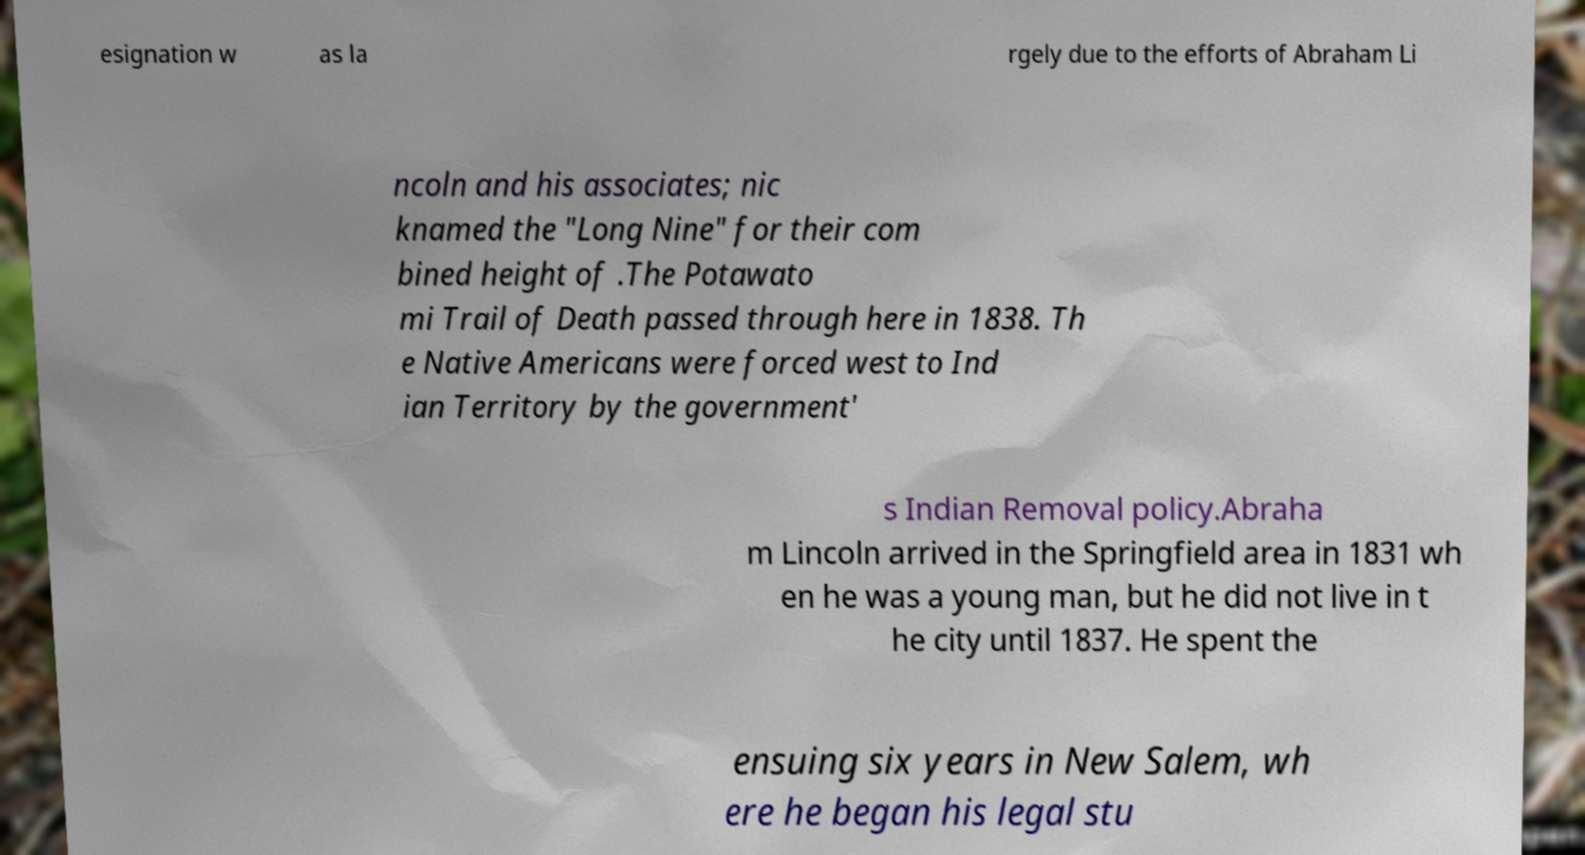There's text embedded in this image that I need extracted. Can you transcribe it verbatim? esignation w as la rgely due to the efforts of Abraham Li ncoln and his associates; nic knamed the "Long Nine" for their com bined height of .The Potawato mi Trail of Death passed through here in 1838. Th e Native Americans were forced west to Ind ian Territory by the government' s Indian Removal policy.Abraha m Lincoln arrived in the Springfield area in 1831 wh en he was a young man, but he did not live in t he city until 1837. He spent the ensuing six years in New Salem, wh ere he began his legal stu 